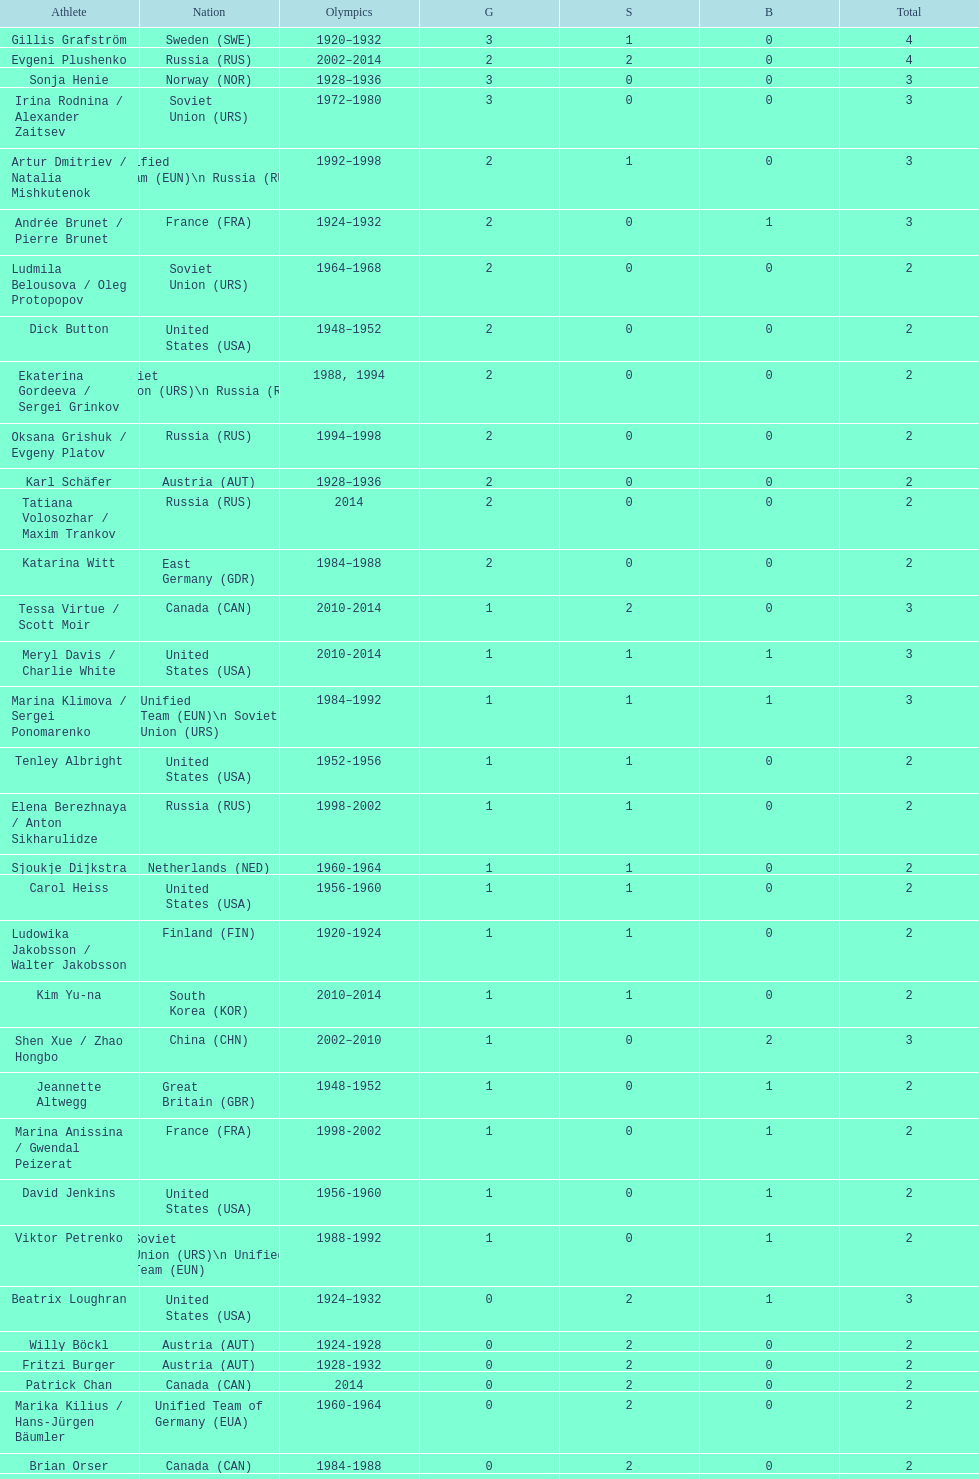What is the sum of medals won by sweden and norway together? 7. 